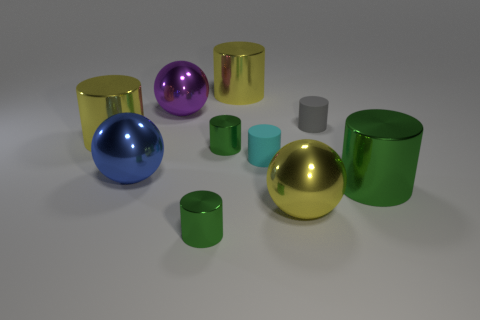What is the size of the blue object that is the same material as the big purple object?
Offer a terse response. Large. What number of other objects are there of the same shape as the small gray matte object?
Your answer should be compact. 6. Does the green thing behind the cyan rubber cylinder have the same size as the rubber object on the right side of the yellow metal sphere?
Offer a terse response. Yes. What number of balls are big purple things or large yellow metallic things?
Offer a terse response. 2. What number of rubber things are either blue spheres or tiny cylinders?
Offer a very short reply. 2. There is a purple thing that is the same shape as the big blue thing; what size is it?
Give a very brief answer. Large. There is a cyan rubber cylinder; does it have the same size as the yellow metallic cylinder that is to the left of the blue metallic ball?
Your answer should be compact. No. The small green thing behind the large blue object has what shape?
Give a very brief answer. Cylinder. What color is the tiny matte cylinder that is on the left side of the yellow object in front of the big blue ball?
Offer a terse response. Cyan. There is another matte thing that is the same shape as the small gray object; what color is it?
Give a very brief answer. Cyan. 